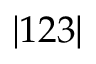Convert formula to latex. <formula><loc_0><loc_0><loc_500><loc_500>| 1 2 3 |</formula> 